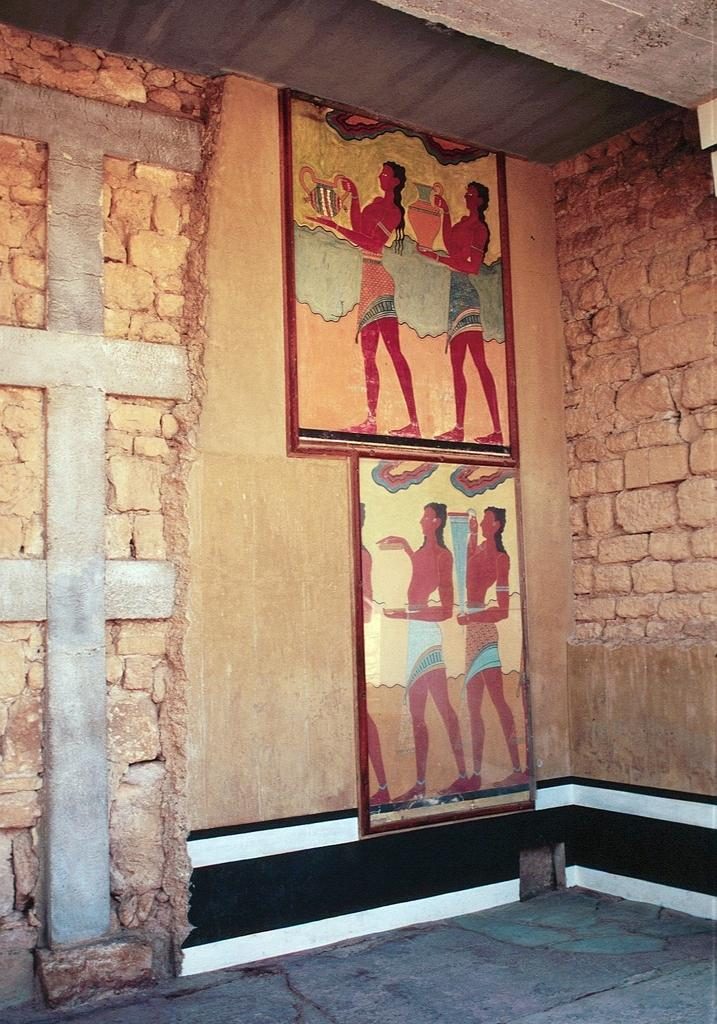What type of decorations can be seen in the image? There are wall hangings in the image. How are the wall hangings secured to the wall? The wall hangings are attached to the wall. What material is the wall made of? The wall is built with cobblestones. What type of eggnog is being served in the image? There is no eggnog present in the image. What type of cracker is used to hang the wall hangings in the image? The wall hangings are attached to the wall directly, without the use of any crackers. 